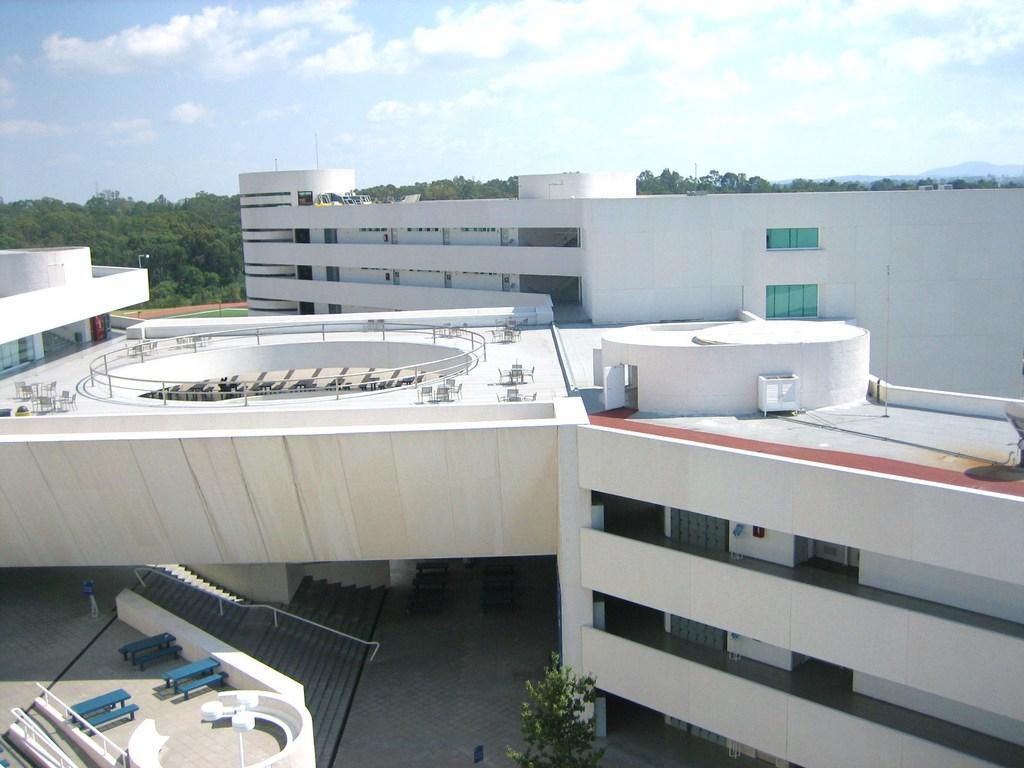How would you summarize this image in a sentence or two? In this image we can see some buildings with windows. We can also see benches, trees, pole and the sky which looks cloudy. 